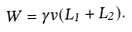Convert formula to latex. <formula><loc_0><loc_0><loc_500><loc_500>W = \gamma v ( L _ { 1 } + L _ { 2 } ) .</formula> 